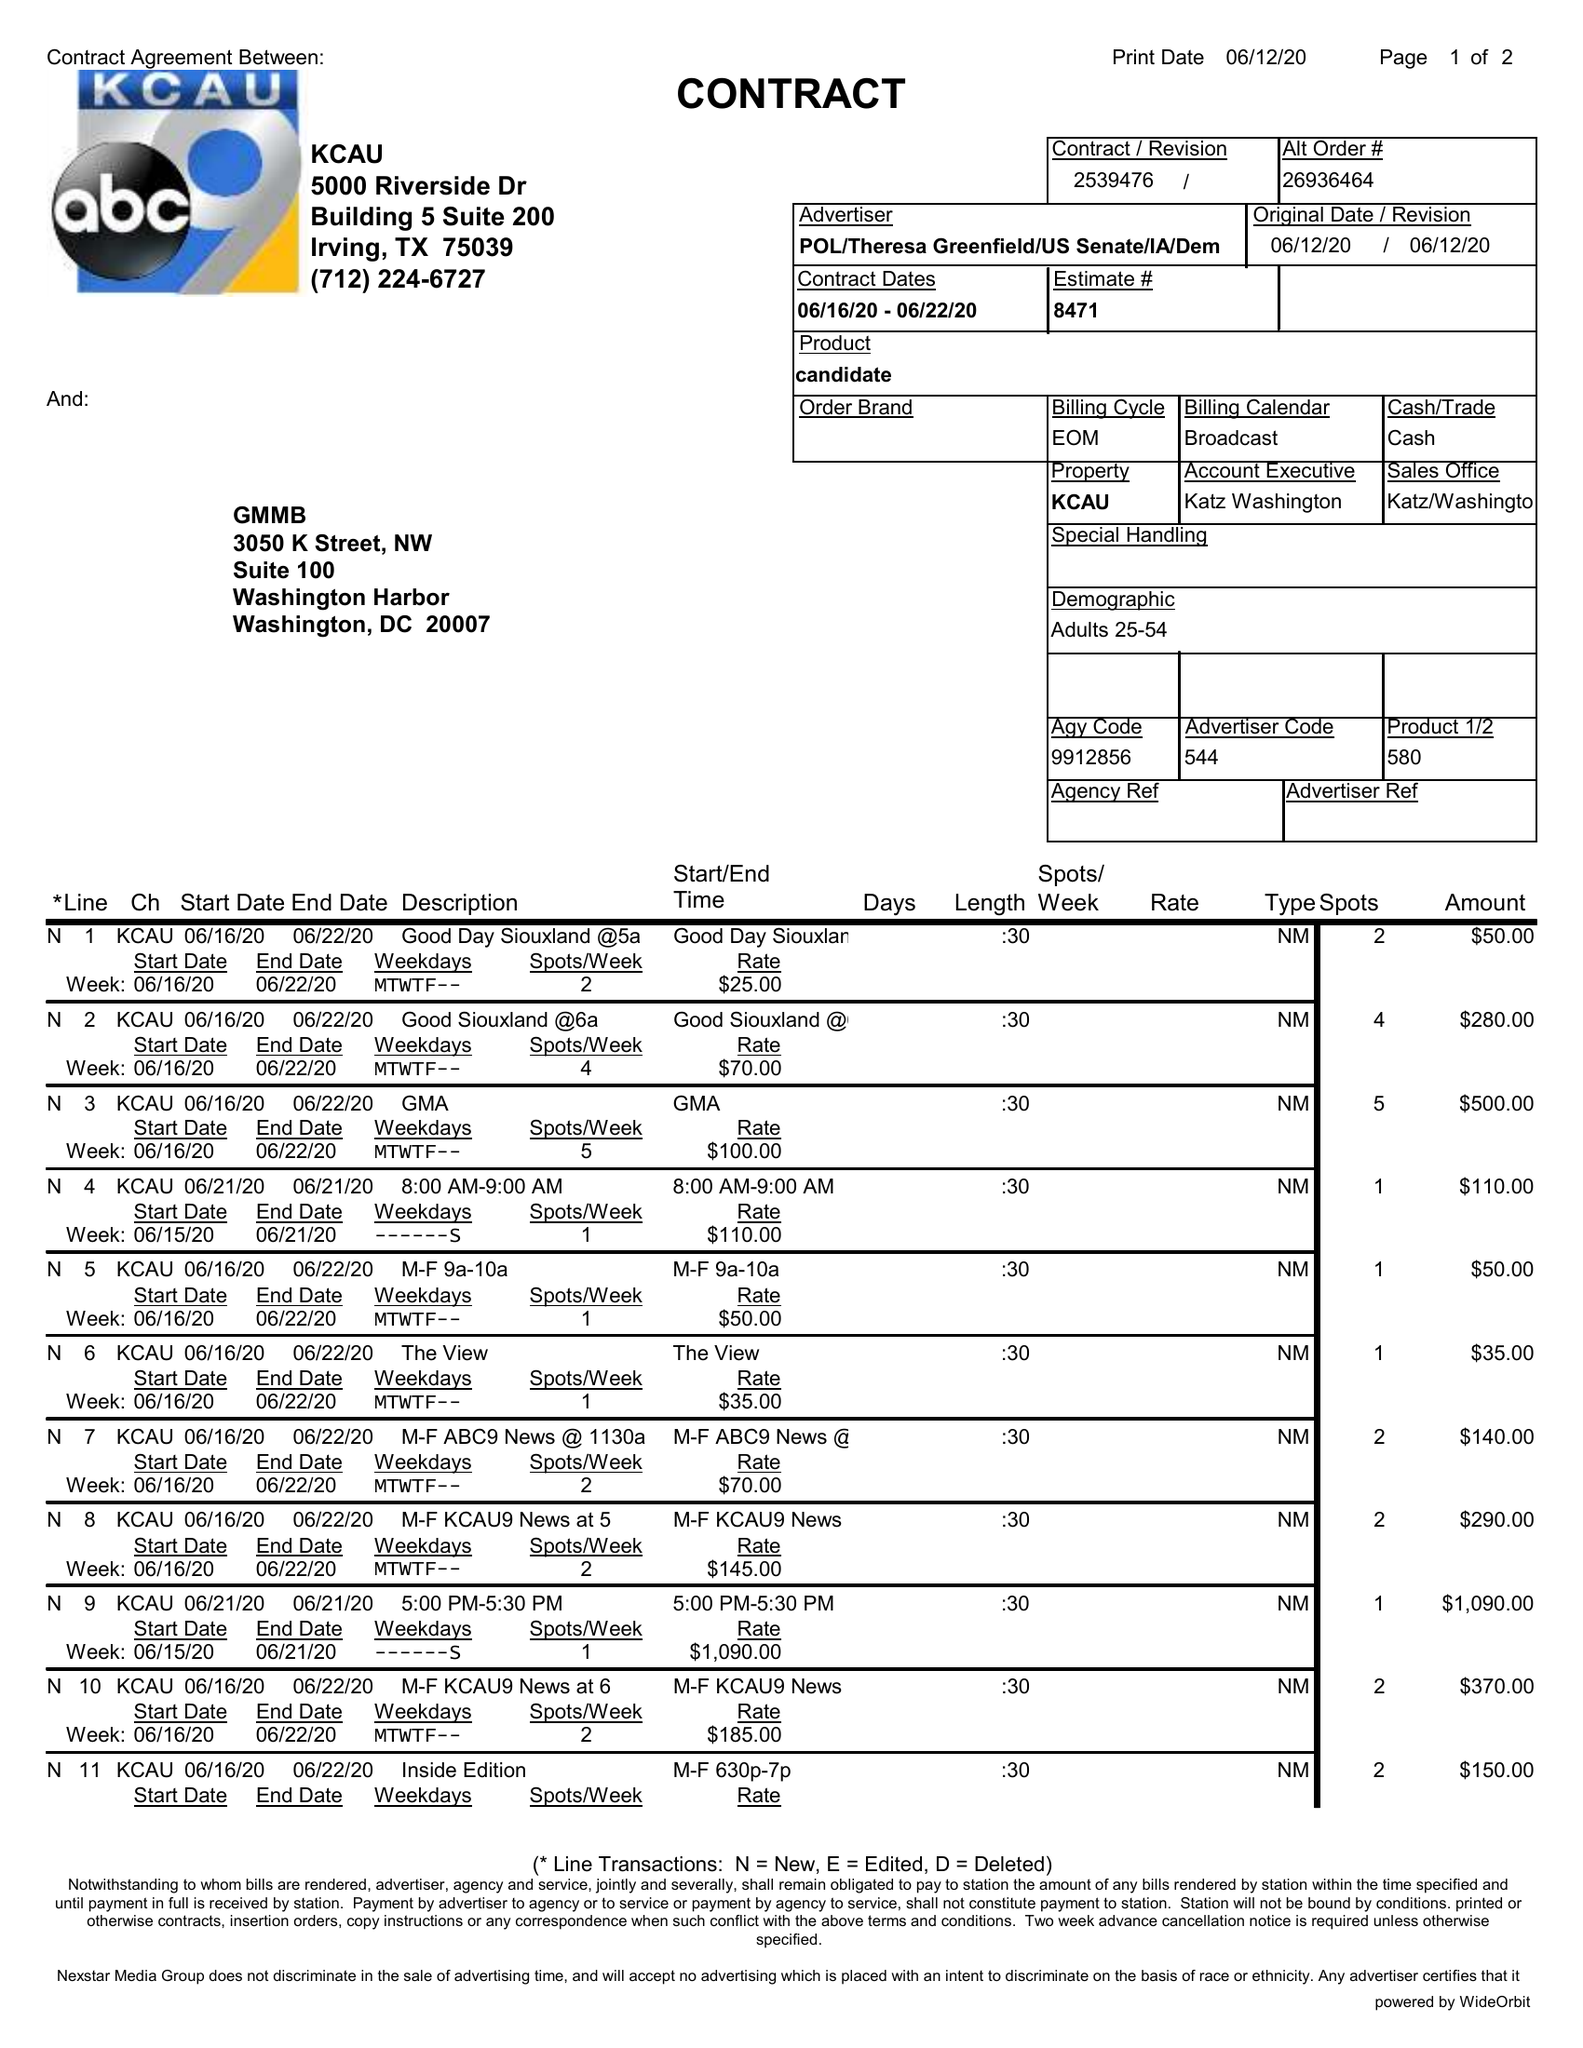What is the value for the gross_amount?
Answer the question using a single word or phrase. 4170.00 